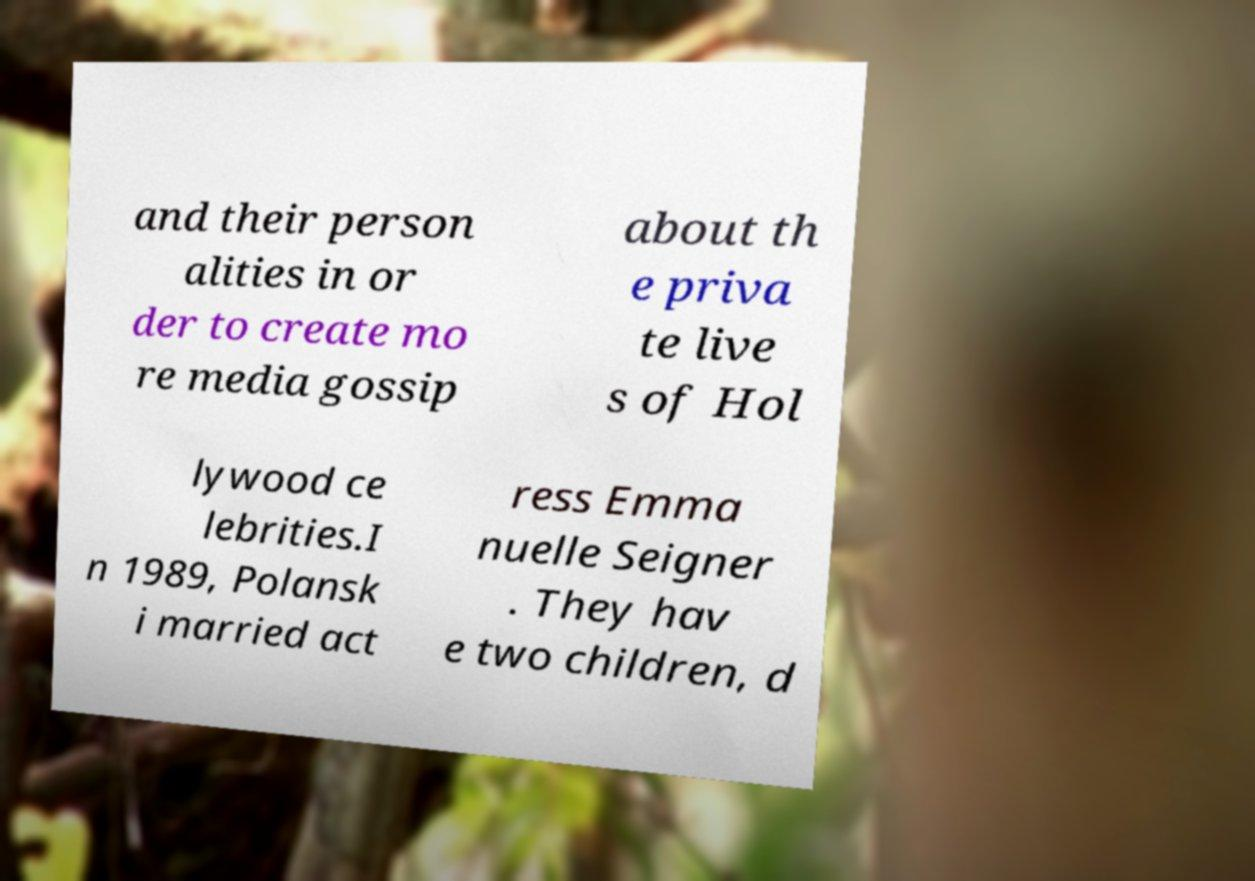Can you read and provide the text displayed in the image?This photo seems to have some interesting text. Can you extract and type it out for me? and their person alities in or der to create mo re media gossip about th e priva te live s of Hol lywood ce lebrities.I n 1989, Polansk i married act ress Emma nuelle Seigner . They hav e two children, d 